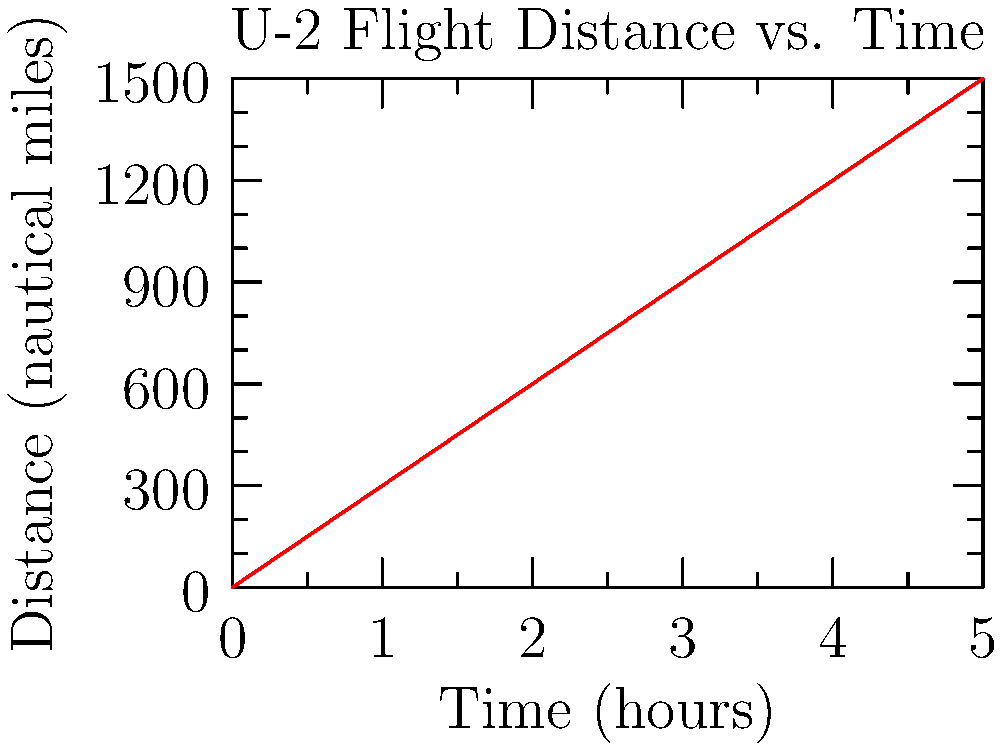A U-2 spy plane flies a reconnaissance mission as shown in the graph above. If the aircraft's fuel consumption rate is 250 gallons per hour, how many gallons of fuel are consumed during the 5-hour flight? To solve this problem, we need to follow these steps:

1. Understand the given information:
   - The flight duration is 5 hours
   - The fuel consumption rate is 250 gallons per hour

2. Calculate the total fuel consumed:
   - Fuel consumed = Fuel consumption rate × Flight duration
   - Fuel consumed = 250 gallons/hour × 5 hours
   - Fuel consumed = 1250 gallons

The graph provides additional information about the distance covered, but it's not necessary for calculating the fuel consumption in this case. The fuel consumption is based on the flight duration and the constant fuel consumption rate.
Answer: 1250 gallons 